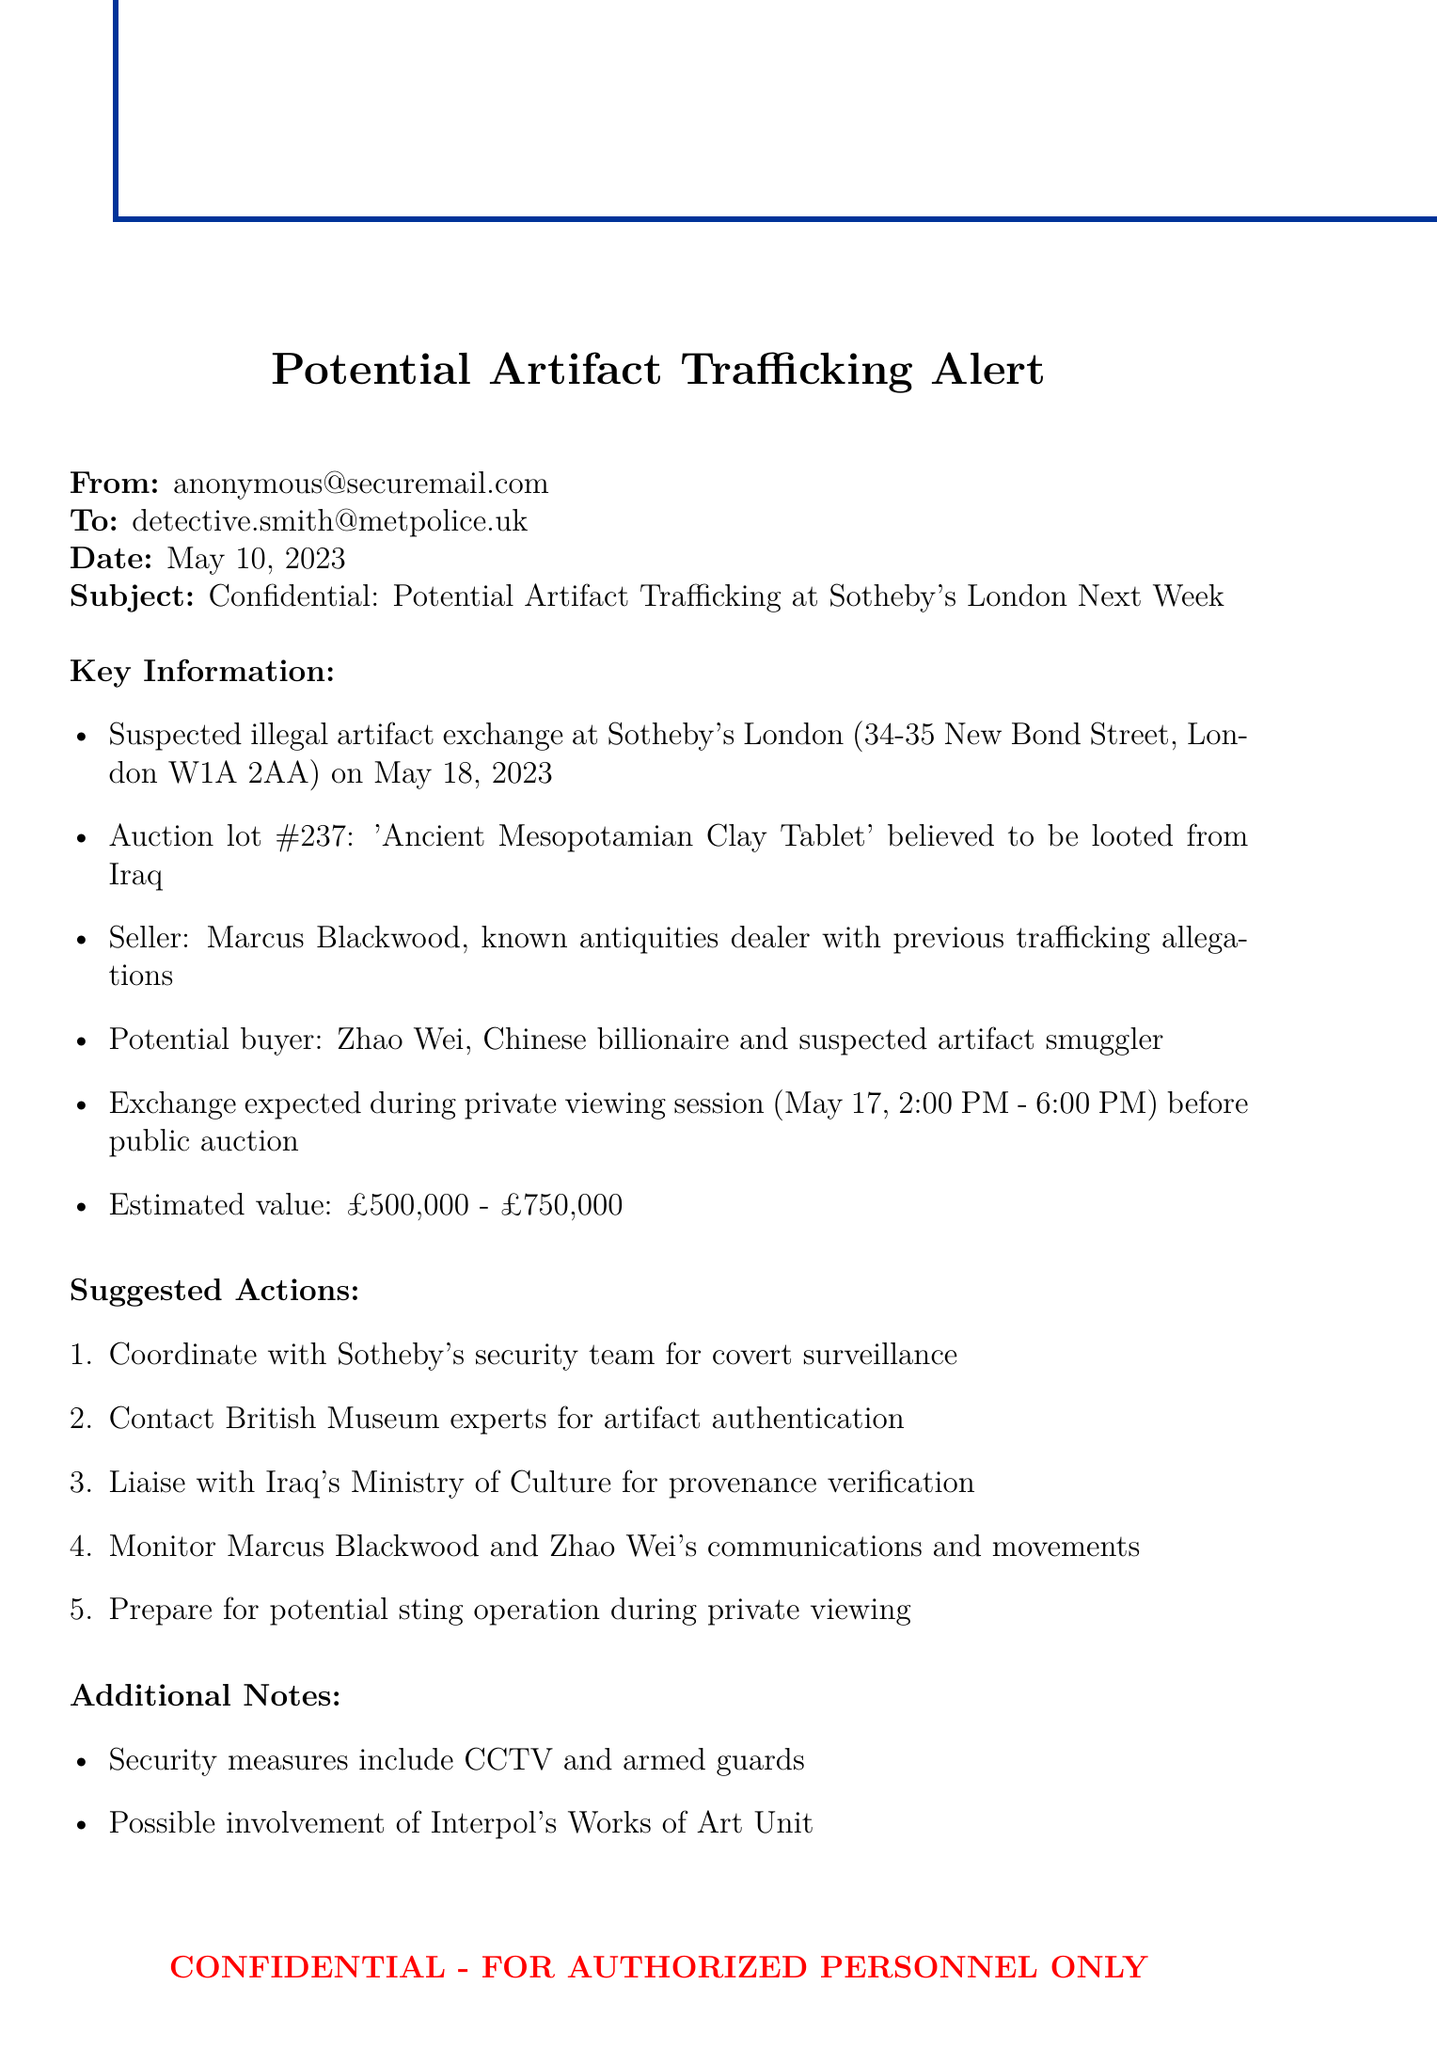What is the date of the suspected artifact exchange? The document states that the suspected artifact exchange is on May 18, 2023.
Answer: May 18, 2023 Who is the seller of the artifact? The seller mentioned in the document is Marcus Blackwood, a known antiquities dealer.
Answer: Marcus Blackwood What is the estimated value of the artifact? The document lists the artifact's estimated value between £500,000 and £750,000.
Answer: £500,000 - £750,000 What is the location of the auction house? The location of Sotheby's is specified as 34-35 New Bond Street, London W1A 2AA.
Answer: 34-35 New Bond Street, London W1A 2AA What action is suggested to monitor the involved individuals? The document suggests monitoring Marcus Blackwood and Zhao Wei's communications and movements.
Answer: Monitor communications and movements What is the name of the potential buyer? The potential buyer identified in the document is Zhao Wei.
Answer: Zhao Wei When is the private viewing session scheduled? The private viewing session is scheduled for May 17, from 2:00 PM to 6:00 PM.
Answer: May 17, 2:00 PM - 6:00 PM What security measures are mentioned in the document? The document lists security measures that include CCTV and armed guards at the auction house.
Answer: CCTV and armed guards What agency might be involved in this case? The document notes the possible involvement of Interpol's Works of Art Unit.
Answer: Interpol's Works of Art Unit 